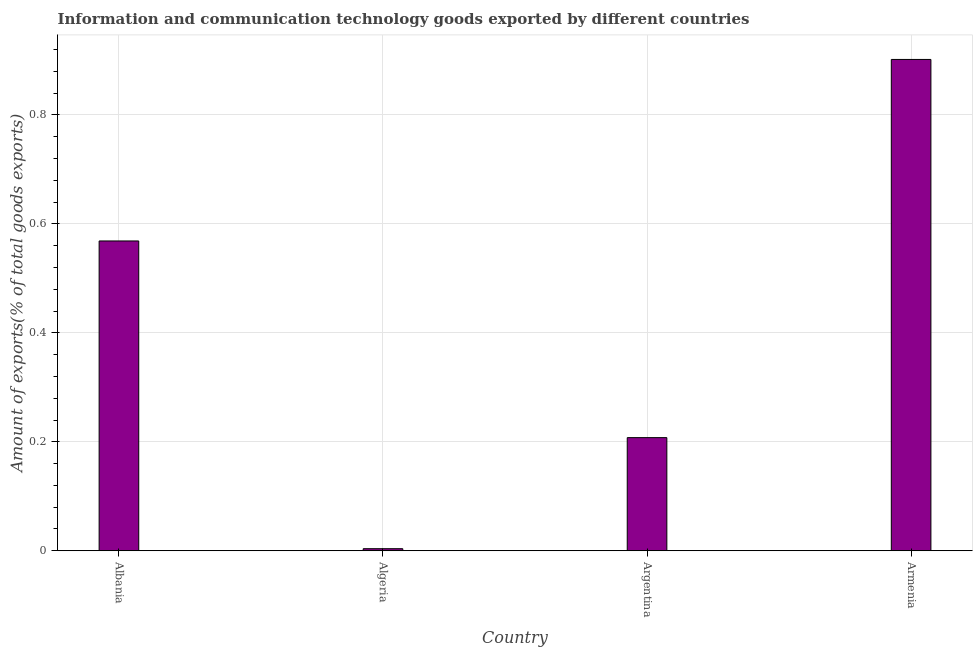What is the title of the graph?
Keep it short and to the point. Information and communication technology goods exported by different countries. What is the label or title of the Y-axis?
Provide a short and direct response. Amount of exports(% of total goods exports). What is the amount of ict goods exports in Argentina?
Your answer should be compact. 0.21. Across all countries, what is the maximum amount of ict goods exports?
Your response must be concise. 0.9. Across all countries, what is the minimum amount of ict goods exports?
Your answer should be very brief. 0. In which country was the amount of ict goods exports maximum?
Provide a short and direct response. Armenia. In which country was the amount of ict goods exports minimum?
Provide a short and direct response. Algeria. What is the sum of the amount of ict goods exports?
Provide a short and direct response. 1.68. What is the difference between the amount of ict goods exports in Albania and Algeria?
Make the answer very short. 0.56. What is the average amount of ict goods exports per country?
Provide a short and direct response. 0.42. What is the median amount of ict goods exports?
Provide a succinct answer. 0.39. What is the ratio of the amount of ict goods exports in Algeria to that in Armenia?
Make the answer very short. 0. Is the difference between the amount of ict goods exports in Albania and Argentina greater than the difference between any two countries?
Offer a very short reply. No. What is the difference between the highest and the second highest amount of ict goods exports?
Provide a succinct answer. 0.33. In how many countries, is the amount of ict goods exports greater than the average amount of ict goods exports taken over all countries?
Keep it short and to the point. 2. How many bars are there?
Offer a terse response. 4. Are all the bars in the graph horizontal?
Your answer should be very brief. No. What is the difference between two consecutive major ticks on the Y-axis?
Your response must be concise. 0.2. Are the values on the major ticks of Y-axis written in scientific E-notation?
Keep it short and to the point. No. What is the Amount of exports(% of total goods exports) in Albania?
Offer a very short reply. 0.57. What is the Amount of exports(% of total goods exports) in Algeria?
Your answer should be very brief. 0. What is the Amount of exports(% of total goods exports) of Argentina?
Your answer should be compact. 0.21. What is the Amount of exports(% of total goods exports) of Armenia?
Your response must be concise. 0.9. What is the difference between the Amount of exports(% of total goods exports) in Albania and Algeria?
Give a very brief answer. 0.56. What is the difference between the Amount of exports(% of total goods exports) in Albania and Argentina?
Your answer should be very brief. 0.36. What is the difference between the Amount of exports(% of total goods exports) in Albania and Armenia?
Offer a very short reply. -0.33. What is the difference between the Amount of exports(% of total goods exports) in Algeria and Argentina?
Offer a terse response. -0.2. What is the difference between the Amount of exports(% of total goods exports) in Algeria and Armenia?
Provide a short and direct response. -0.9. What is the difference between the Amount of exports(% of total goods exports) in Argentina and Armenia?
Your answer should be very brief. -0.69. What is the ratio of the Amount of exports(% of total goods exports) in Albania to that in Algeria?
Your answer should be compact. 149.49. What is the ratio of the Amount of exports(% of total goods exports) in Albania to that in Argentina?
Give a very brief answer. 2.74. What is the ratio of the Amount of exports(% of total goods exports) in Albania to that in Armenia?
Offer a terse response. 0.63. What is the ratio of the Amount of exports(% of total goods exports) in Algeria to that in Argentina?
Give a very brief answer. 0.02. What is the ratio of the Amount of exports(% of total goods exports) in Algeria to that in Armenia?
Ensure brevity in your answer.  0. What is the ratio of the Amount of exports(% of total goods exports) in Argentina to that in Armenia?
Offer a very short reply. 0.23. 